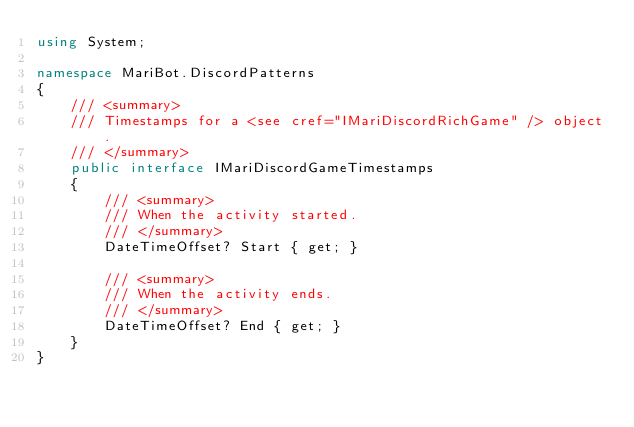<code> <loc_0><loc_0><loc_500><loc_500><_C#_>using System;

namespace MariBot.DiscordPatterns
{
    /// <summary>
    /// Timestamps for a <see cref="IMariDiscordRichGame" /> object.
    /// </summary>
    public interface IMariDiscordGameTimestamps
    {
        /// <summary>
        /// When the activity started.
        /// </summary>
        DateTimeOffset? Start { get; }

        /// <summary>
        /// When the activity ends.
        /// </summary>
        DateTimeOffset? End { get; }
    }
}</code> 